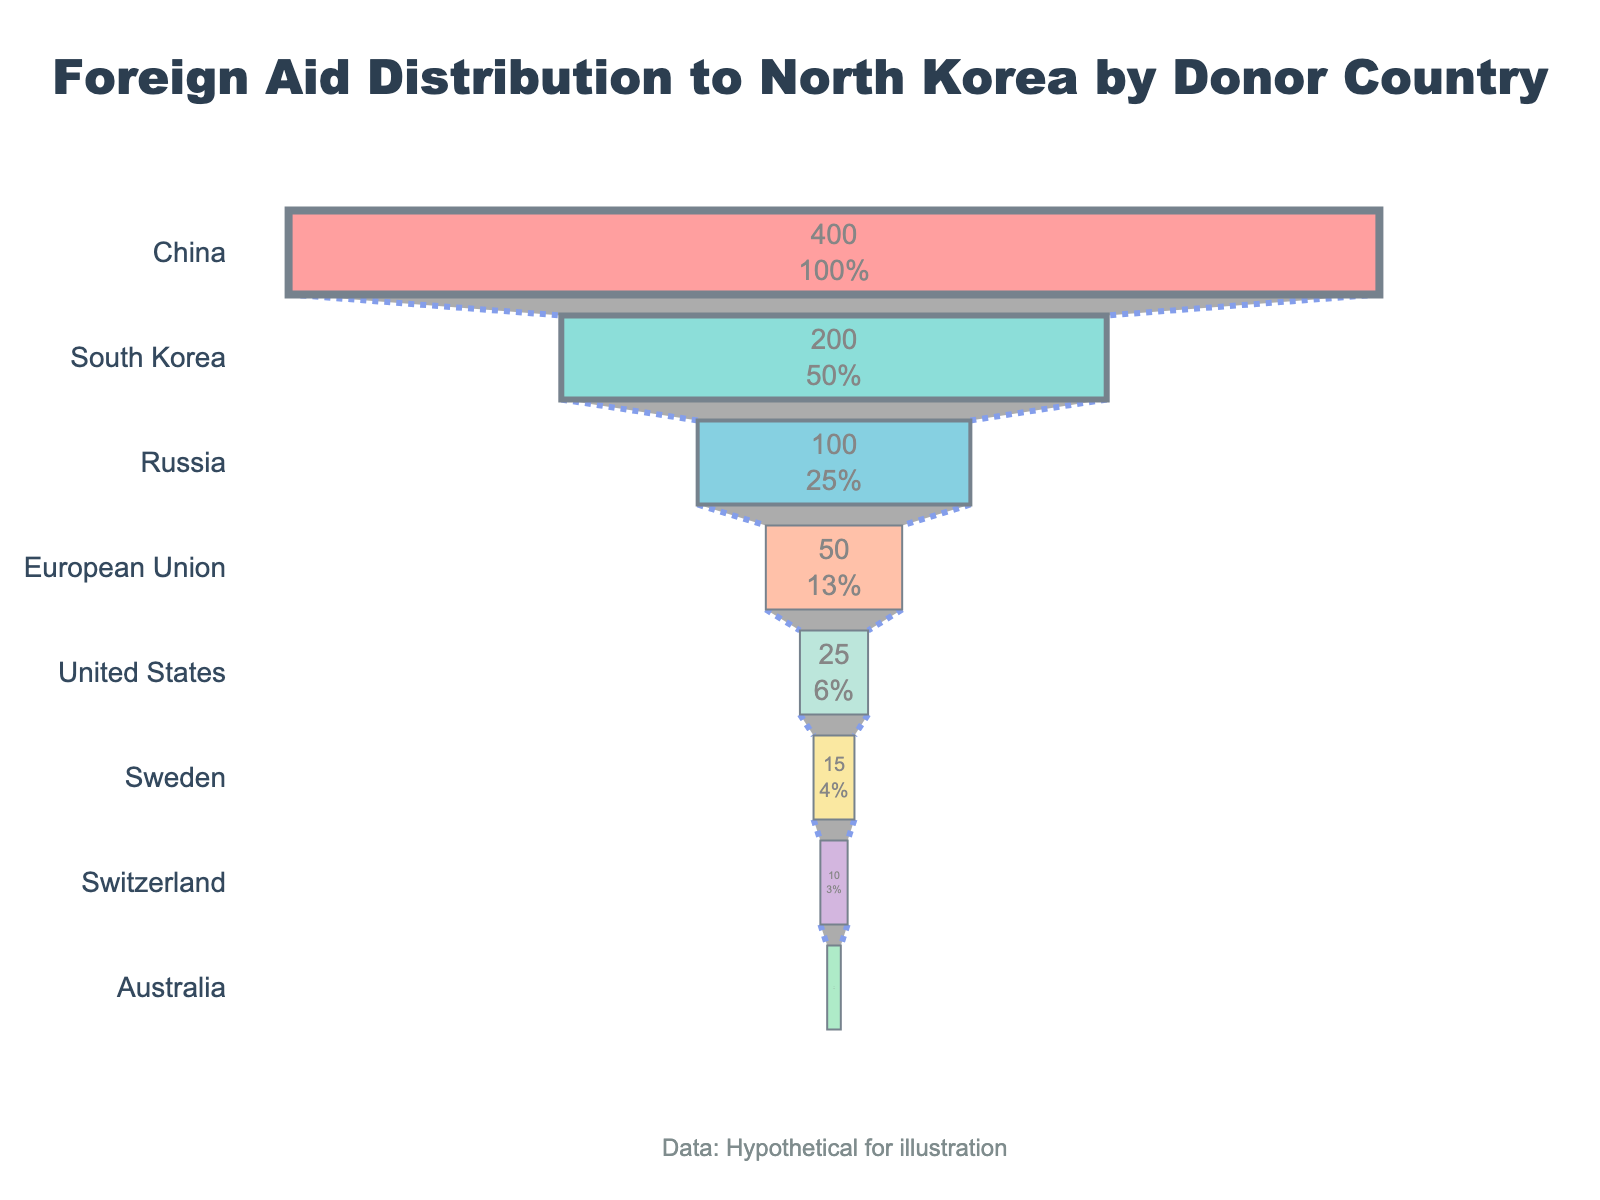Which country provides the most foreign aid to North Korea? The funnel chart shows that China is at the top with the largest amount indicated in millions of USD.
Answer: China What is the total amount of aid provided by the top three donor countries? Sum the aid amounts from China (400), South Korea (200), and Russia (100). 400 + 200 + 100 = 700
Answer: 700 million USD How much more aid does China provide compared to the United States? Subtract the amount given by the United States (25) from the amount given by China (400). 400 - 25 = 375
Answer: 375 million USD Which country contributes half of the aid that South Korea provides? South Korea contributes 200 million USD. Half of this is 100 million USD. Russia contributes exactly 100 million USD.
Answer: Russia What percentage of the total aid is provided by Switzerland? First, find the total aid provided by summing all the amounts. Total = 400 + 200 + 100 + 50 + 25 + 15 + 10 + 5 = 805. Switzerland provides 10 million USD. (10 / 805) * 100 ≈ 1.24%
Answer: ≈ 1.24% How many countries provide less than 50 million USD in aid? The funnel chart indicates Sweden (15), Switzerland (10), and Australia (5) provide less than 50 million USD in aid.
Answer: 3 countries What is the median amount of aid provided by the donor countries? List the aid amounts in ascending order: 5, 10, 15, 25, 50, 100, 200, 400. The median is the average of the 4th and 5th values. (25 + 50) / 2 = 37.5
Answer: 37.5 million USD Which two countries together contribute the same amount of aid as China? South Korea and Russia together contribute 200 + 100 = 300, which is less than 400. South Korea, Russia, and European Union contribute 200 + 100 + 50 = 350, which is also less than 400. Thus, no two countries can match China's contribution.
Answer: None Does Sweden contribute more aid than Australia and Switzerland combined? The contributions are Sweden (15) and Australia (5) plus Switzerland (10). 5 + 10 = 15. Sweden's contribution is equal to the combined contributions of Australia and Switzerland.
Answer: No, it’s equal Which country provides the least amount of foreign aid? According to the funnel chart, Australia is at the bottom with 5 million USD.
Answer: Australia 